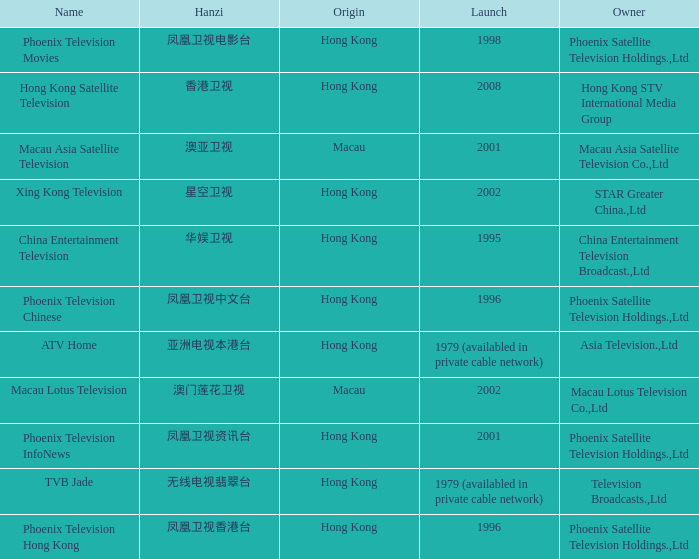What is the Hanzi of Hong Kong in 1998? 凤凰卫视电影台. 